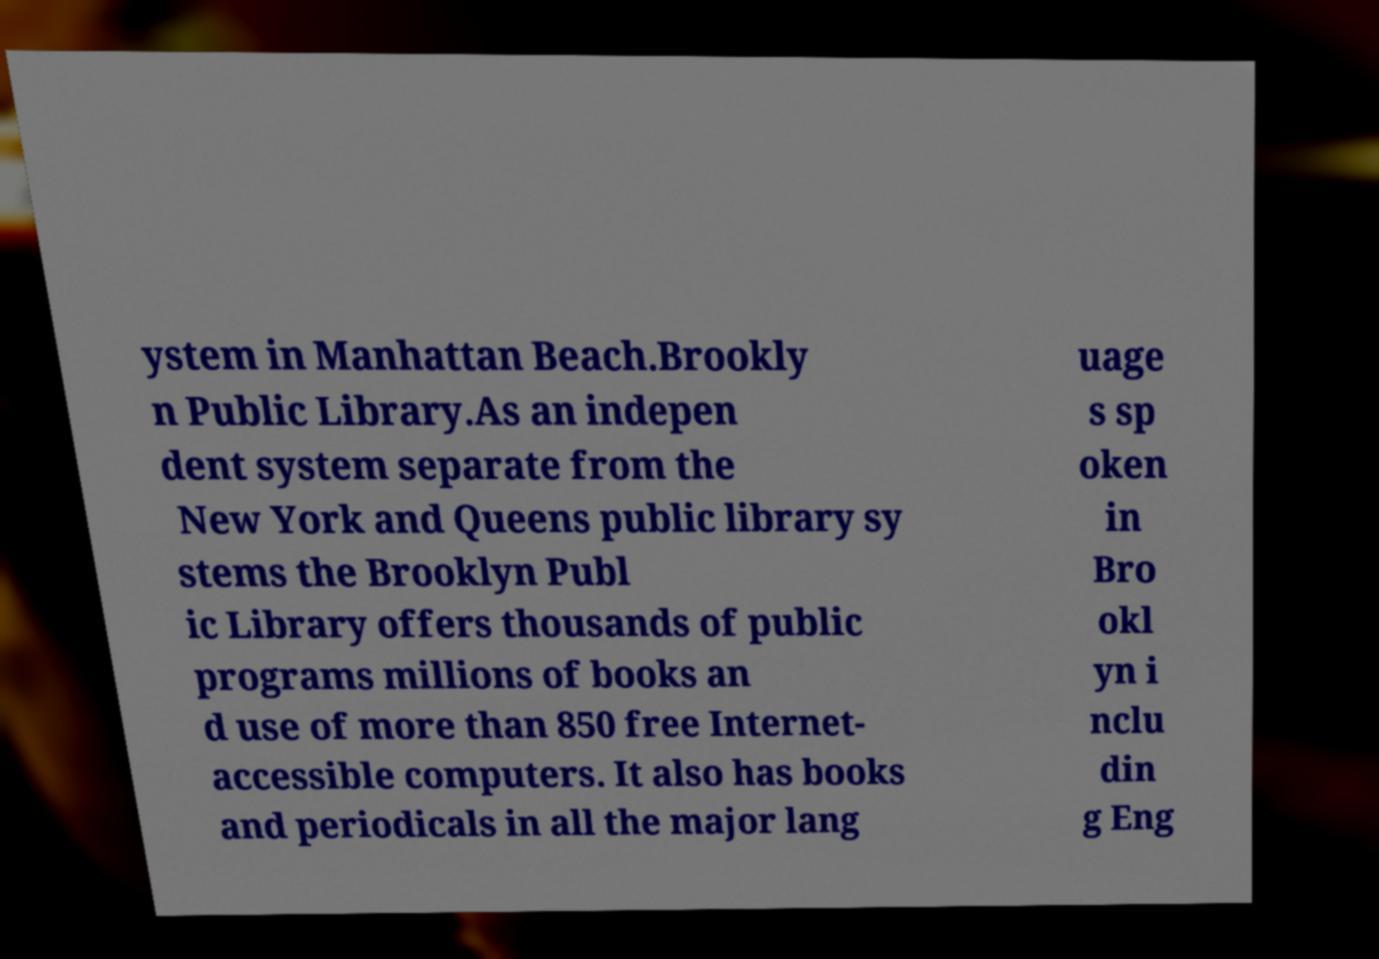Could you extract and type out the text from this image? ystem in Manhattan Beach.Brookly n Public Library.As an indepen dent system separate from the New York and Queens public library sy stems the Brooklyn Publ ic Library offers thousands of public programs millions of books an d use of more than 850 free Internet- accessible computers. It also has books and periodicals in all the major lang uage s sp oken in Bro okl yn i nclu din g Eng 